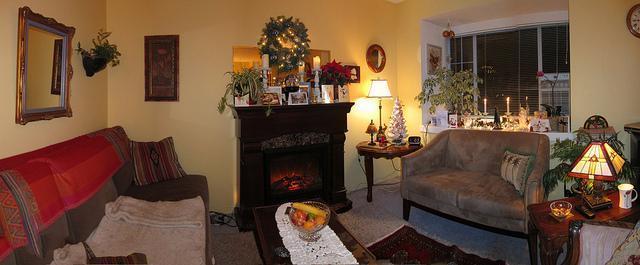How many potted plants are there?
Give a very brief answer. 2. How many couches can be seen?
Give a very brief answer. 2. How many people are riding bikes?
Give a very brief answer. 0. 